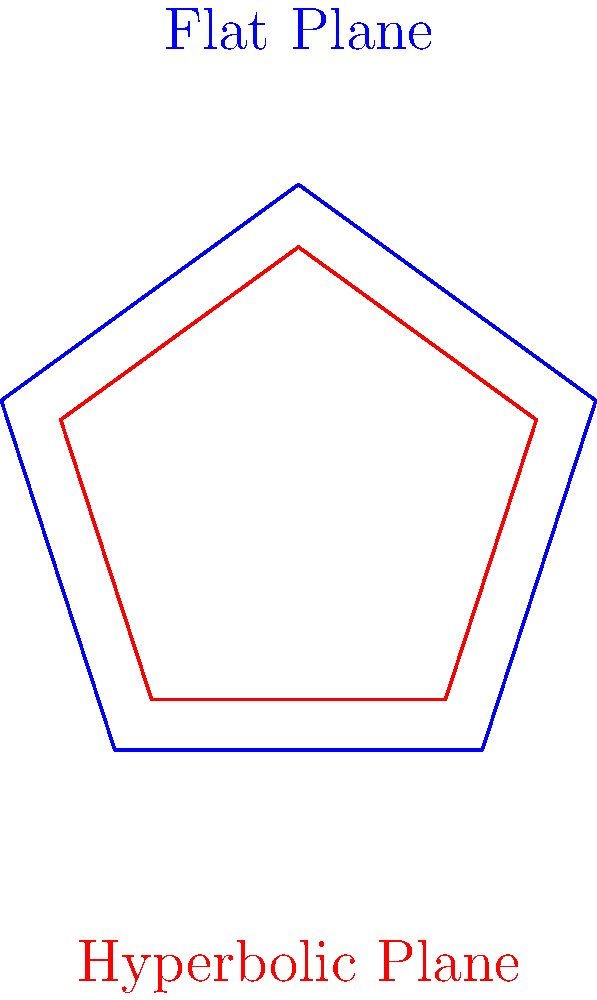Consider a regular pentagon on a flat plane and a regular pentagon on a hyperbolic plane, both with side length 1. Which of the following statements is true regarding their interior angles?

A) The interior angles of both pentagons are equal.
B) The interior angles of the pentagon on the hyperbolic plane are larger.
C) The interior angles of the pentagon on the hyperbolic plane are smaller.
D) The interior angles depend on the curvature of the hyperbolic plane. Let's approach this step-by-step:

1) On a flat (Euclidean) plane:
   - The formula for the interior angle of a regular n-gon is: $$(n-2) \times \frac{180°}{n}$$
   - For a pentagon (n=5): $$(5-2) \times \frac{180°}{5} = 108°$$

2) On a hyperbolic plane:
   - The sum of interior angles of a polygon is always less than $$(n-2) \times 180°$$
   - This means each interior angle must be less than in the Euclidean case

3) The exact measure of the interior angles on a hyperbolic plane depends on the curvature of the plane. More negative curvature results in smaller interior angles.

4) However, regardless of the specific curvature, the interior angles of a regular pentagon on a hyperbolic plane will always be smaller than 108°.

Therefore, the correct statement is that the interior angles of the pentagon on the hyperbolic plane are smaller than those on the flat plane.
Answer: C 